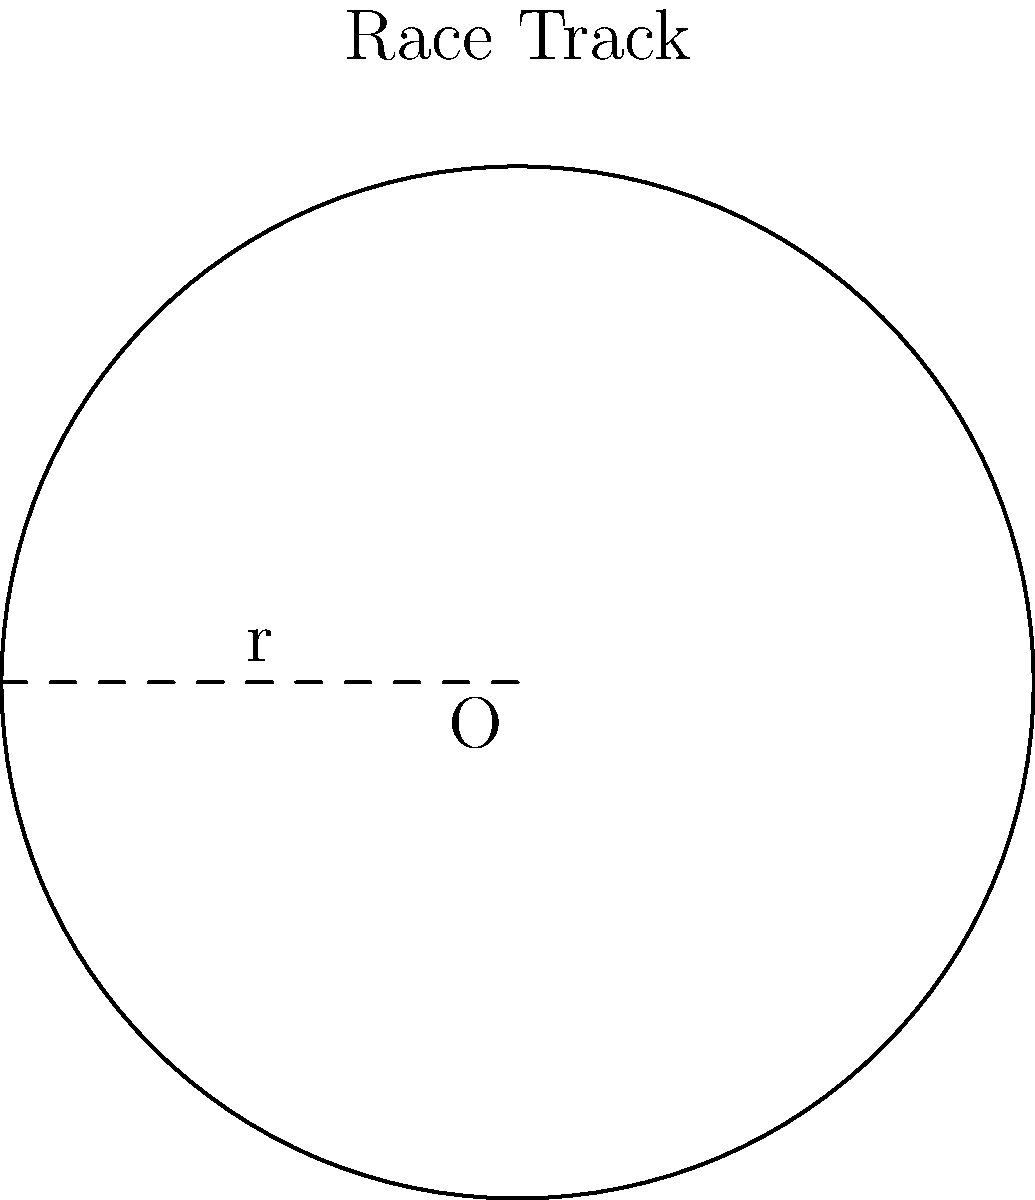As a retro racing game enthusiast, you're analyzing the design of a classic circular race track. The track has a radius of 250 meters. What is the circumference of this race track, rounded to the nearest meter? To find the circumference of a circular race track, we can use the formula:

$$C = 2\pi r$$

Where:
$C$ = circumference
$\pi$ = pi (approximately 3.14159)
$r$ = radius

Given:
$r = 250$ meters

Step 1: Substitute the values into the formula
$$C = 2\pi(250)$$

Step 2: Calculate
$$C = 2 * 3.14159 * 250$$
$$C = 1570.795 \text{ meters}$$

Step 3: Round to the nearest meter
$$C \approx 1571 \text{ meters}$$

This circumference represents the total distance a car would travel to complete one lap around the classic circular race track in your retro racing game.
Answer: 1571 meters 